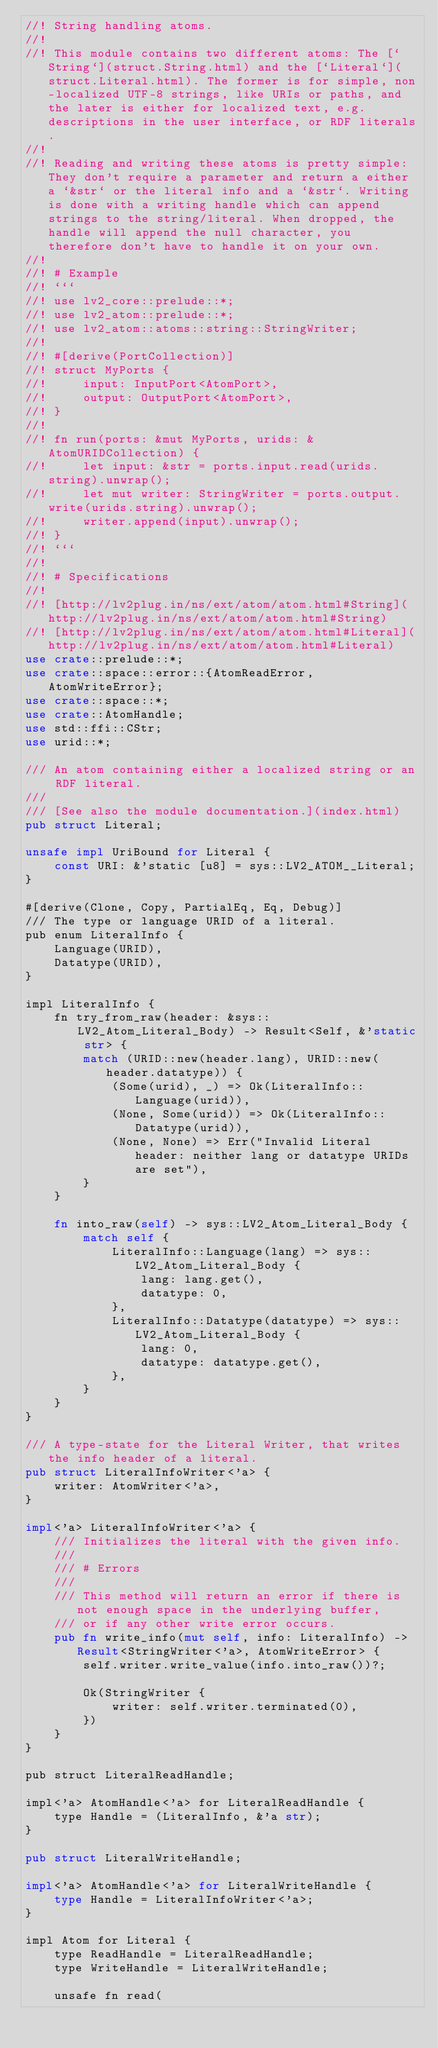<code> <loc_0><loc_0><loc_500><loc_500><_Rust_>//! String handling atoms.
//!
//! This module contains two different atoms: The [`String`](struct.String.html) and the [`Literal`](struct.Literal.html). The former is for simple, non-localized UTF-8 strings, like URIs or paths, and the later is either for localized text, e.g. descriptions in the user interface, or RDF literals.
//!
//! Reading and writing these atoms is pretty simple: They don't require a parameter and return a either a `&str` or the literal info and a `&str`. Writing is done with a writing handle which can append strings to the string/literal. When dropped, the handle will append the null character, you therefore don't have to handle it on your own.
//!
//! # Example
//! ```
//! use lv2_core::prelude::*;
//! use lv2_atom::prelude::*;
//! use lv2_atom::atoms::string::StringWriter;
//!
//! #[derive(PortCollection)]
//! struct MyPorts {
//!     input: InputPort<AtomPort>,
//!     output: OutputPort<AtomPort>,
//! }
//!
//! fn run(ports: &mut MyPorts, urids: &AtomURIDCollection) {
//!     let input: &str = ports.input.read(urids.string).unwrap();
//!     let mut writer: StringWriter = ports.output.write(urids.string).unwrap();
//!     writer.append(input).unwrap();
//! }
//! ```
//!
//! # Specifications
//!
//! [http://lv2plug.in/ns/ext/atom/atom.html#String](http://lv2plug.in/ns/ext/atom/atom.html#String)
//! [http://lv2plug.in/ns/ext/atom/atom.html#Literal](http://lv2plug.in/ns/ext/atom/atom.html#Literal)
use crate::prelude::*;
use crate::space::error::{AtomReadError, AtomWriteError};
use crate::space::*;
use crate::AtomHandle;
use std::ffi::CStr;
use urid::*;

/// An atom containing either a localized string or an RDF literal.
///
/// [See also the module documentation.](index.html)
pub struct Literal;

unsafe impl UriBound for Literal {
    const URI: &'static [u8] = sys::LV2_ATOM__Literal;
}

#[derive(Clone, Copy, PartialEq, Eq, Debug)]
/// The type or language URID of a literal.
pub enum LiteralInfo {
    Language(URID),
    Datatype(URID),
}

impl LiteralInfo {
    fn try_from_raw(header: &sys::LV2_Atom_Literal_Body) -> Result<Self, &'static str> {
        match (URID::new(header.lang), URID::new(header.datatype)) {
            (Some(urid), _) => Ok(LiteralInfo::Language(urid)),
            (None, Some(urid)) => Ok(LiteralInfo::Datatype(urid)),
            (None, None) => Err("Invalid Literal header: neither lang or datatype URIDs are set"),
        }
    }

    fn into_raw(self) -> sys::LV2_Atom_Literal_Body {
        match self {
            LiteralInfo::Language(lang) => sys::LV2_Atom_Literal_Body {
                lang: lang.get(),
                datatype: 0,
            },
            LiteralInfo::Datatype(datatype) => sys::LV2_Atom_Literal_Body {
                lang: 0,
                datatype: datatype.get(),
            },
        }
    }
}

/// A type-state for the Literal Writer, that writes the info header of a literal.
pub struct LiteralInfoWriter<'a> {
    writer: AtomWriter<'a>,
}

impl<'a> LiteralInfoWriter<'a> {
    /// Initializes the literal with the given info.
    ///
    /// # Errors
    ///
    /// This method will return an error if there is not enough space in the underlying buffer,
    /// or if any other write error occurs.
    pub fn write_info(mut self, info: LiteralInfo) -> Result<StringWriter<'a>, AtomWriteError> {
        self.writer.write_value(info.into_raw())?;

        Ok(StringWriter {
            writer: self.writer.terminated(0),
        })
    }
}

pub struct LiteralReadHandle;

impl<'a> AtomHandle<'a> for LiteralReadHandle {
    type Handle = (LiteralInfo, &'a str);
}

pub struct LiteralWriteHandle;

impl<'a> AtomHandle<'a> for LiteralWriteHandle {
    type Handle = LiteralInfoWriter<'a>;
}

impl Atom for Literal {
    type ReadHandle = LiteralReadHandle;
    type WriteHandle = LiteralWriteHandle;

    unsafe fn read(</code> 